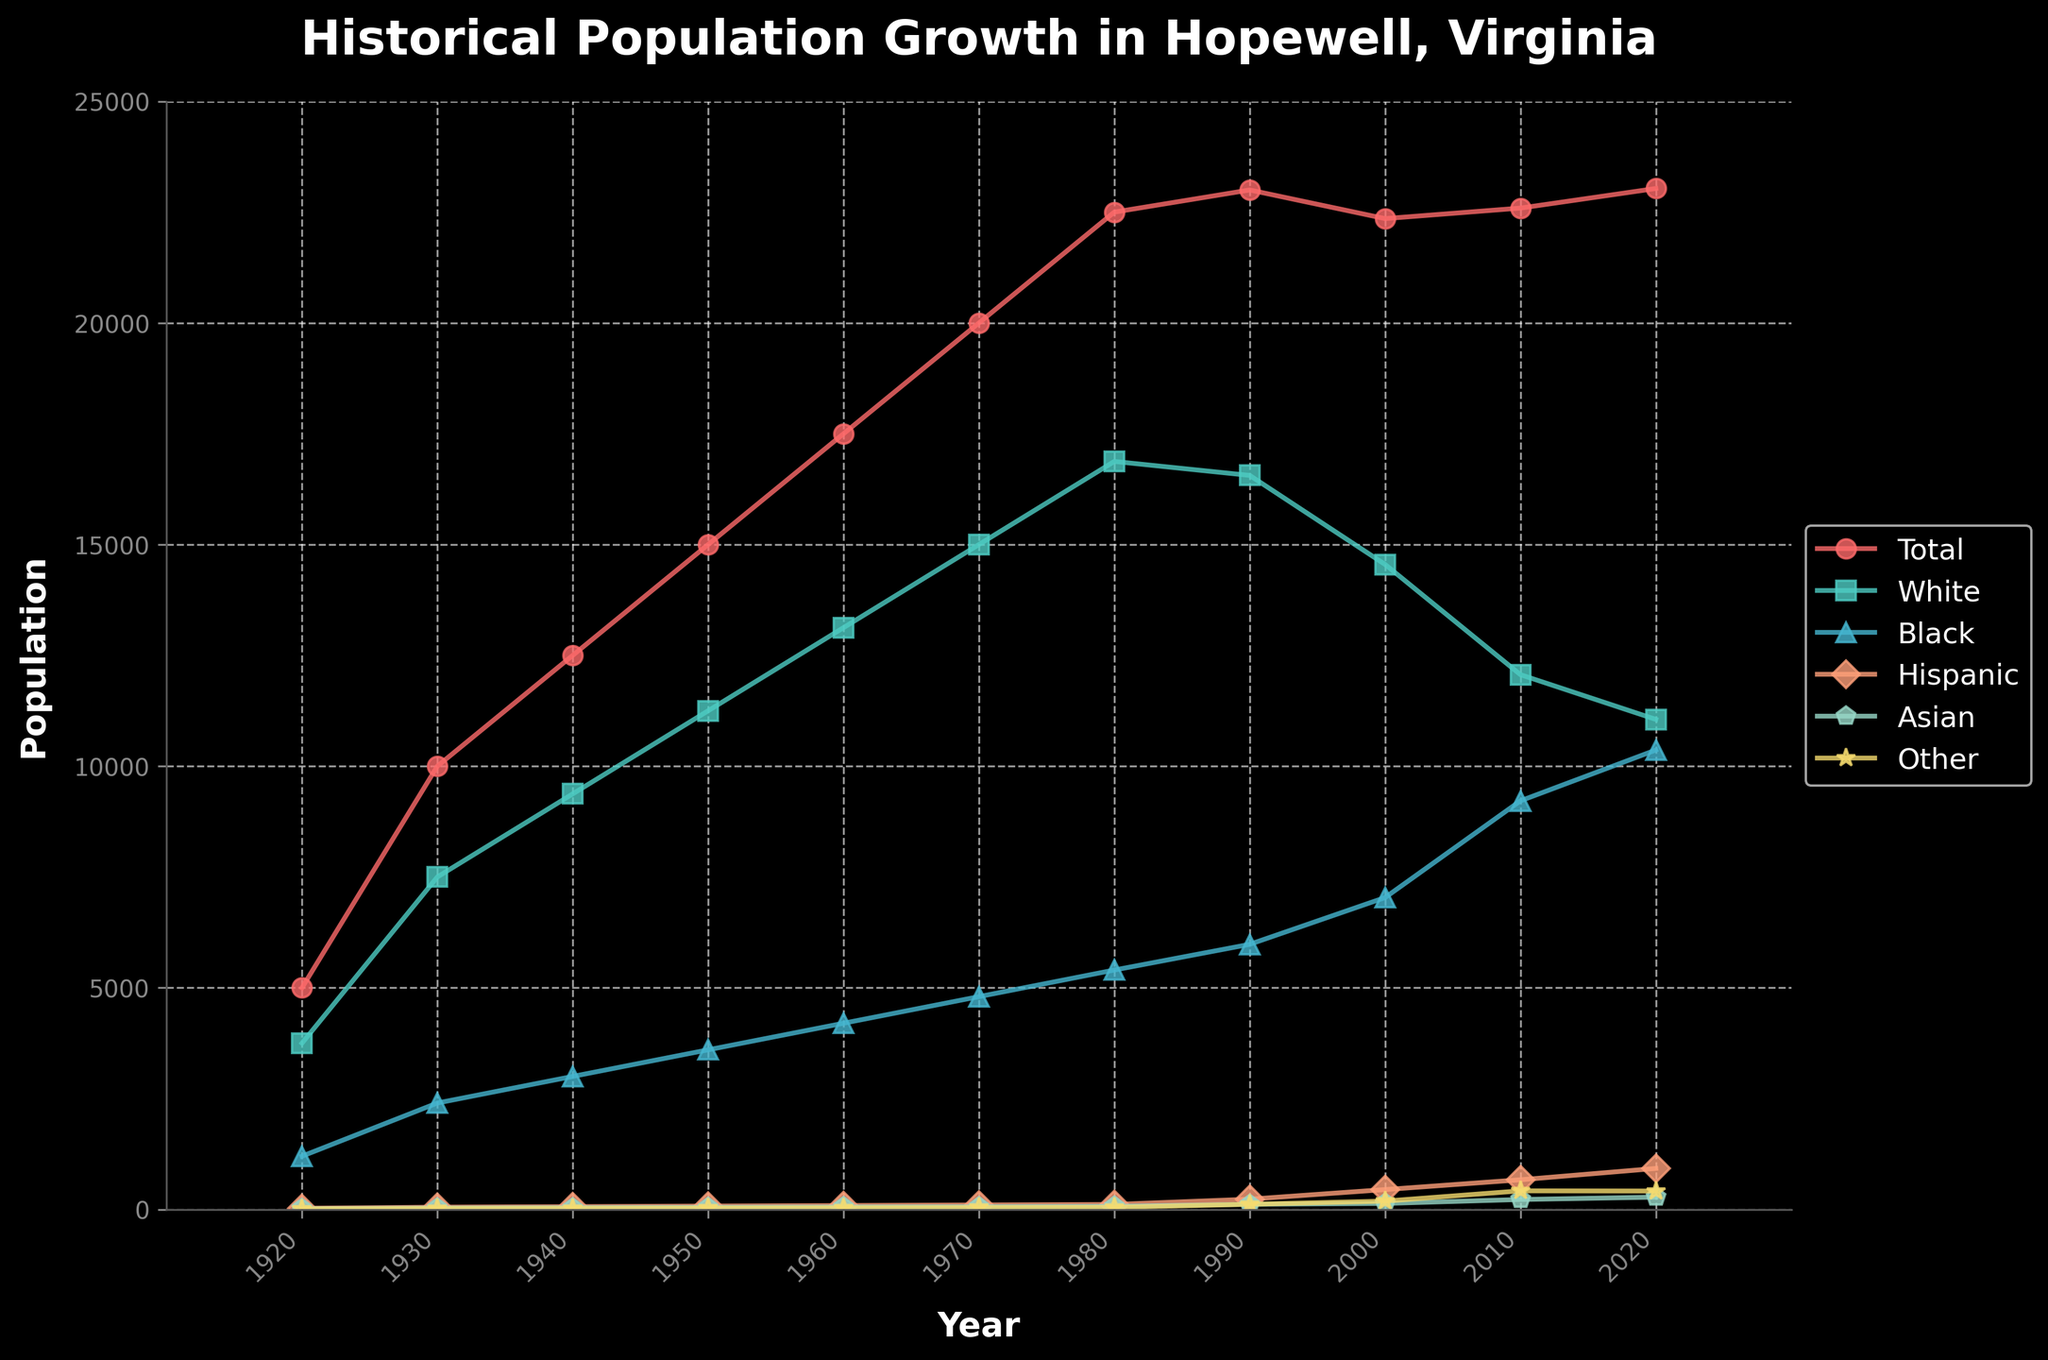What is the population trend of the Hispanic group from 1920 to 2020? The Hispanic population shows a gradual and steady increase over time, growing from a small number (25 in 1920) to 924 in 2020. This progression is consistent and upward throughout the years.
Answer: Steady increase In which year did the population of the Black group surpass the population of the White group? The population of the Black group does not surpass the population of the White group in any of the listed years. The White population remains higher throughout the timeframe.
Answer: Never Which racial group had the biggest population decrease between any two consecutive decades, and during which decades did this occur? The White group experienced the largest population decrease between 2000 and 2010, where its population dropped from 14551 to 12064, a decrease of 2487 people.
Answer: White, 2000-2010 How did the total population trend from 1990 to 2020, and what might this indicate about population growth in general? The total population shows a slight decline from 23000 in 1990 to 22354 in 2000, followed by a small increase to 22591 in 2010 and then to 23033 in 2020. This indicates that overall population growth has slowed down and is relatively stable with minor fluctuations.
Answer: Slow and stable growth Compare the population growth of the Asian group to the Other group from 1920 to 2020. Which group had a larger increase? The Asian group increased from 15 in 1920 to 276 in 2020, a net increase of 261. The Other group increased from 10 in 1920 to 414 in 2020, a net increase of 404. Thus, the Other group had a larger increase over the century.
Answer: Other group What visual cue can help quickly identify which group had the highest population in any given year? The height of the lines in the plot helps to identify the population size. The group represented by the highest line in any given year has the highest population.
Answer: Line height In what years did the total population of Hopewell, Virginia, reach or exceed 20000? The total population reached or exceeded 20000 in 1970, with 20000 and continued to exceed this number through the subsequent decades up to 2020.
Answer: 1970, 1980, 1990, 2010, 2020 What can you infer about the population diversity in recent years compared to the early 20th century? The population by race and ethnicity in recent years (2020) is more diverse compared to the early 20th century (1920). In 1920, the overwhelming majority of the population was White or Black with very few from other groups. By 2020, there were significant increases across other racial and ethnic groups, including Hispanic, Asian, and Other categories.
Answer: Increased diversity 